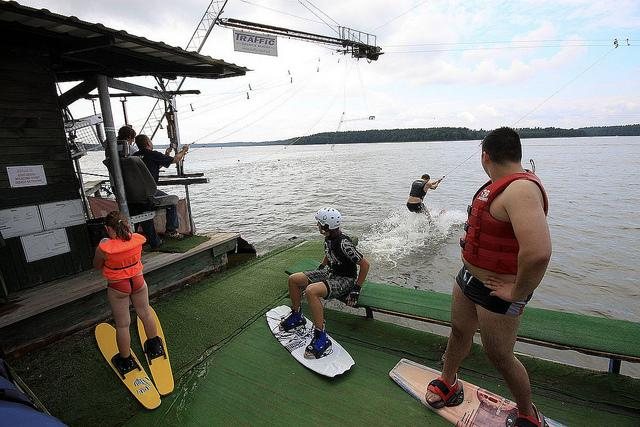What is the man wearing in red? life jacket 